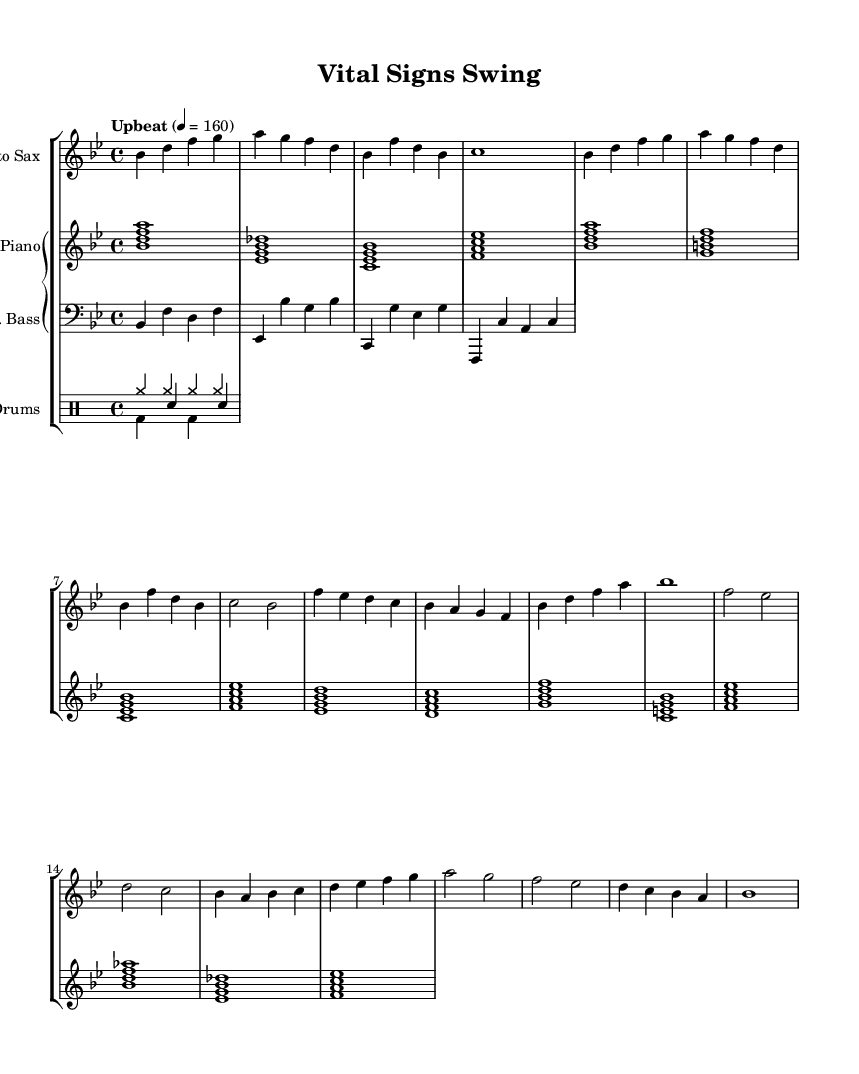What is the key signature of this music? The key signature is identified at the beginning of the sheet music, represented by the flat symbols. In this case, there are two flats (B flat and E flat) listed, indicating that the key is B flat major.
Answer: B flat major What is the time signature of this music? The time signature indicates how many beats are in each measure, shown at the beginning of the sheet music. Here, it is listed as 4/4, meaning there are four beats per measure, and the quarter note gets one beat.
Answer: 4/4 What is the tempo marking for this piece? The tempo marking is found in the first section of the sheet music and indicates the speed at which the piece should be played. It is described as "Upbeat" with a metronome marking of 160 beats per minute.
Answer: Upbeat, 160 How many measures are in the A Section? The A Section is a contained part of the music indicated by distinct musical phrases. Upon counting the measures, there are a total of 8 measures in the A Section of the music.
Answer: 8 What type of instruments are included in this arrangement? The instrument names are specified for each staff. Based on the provided parts, the instruments included are Alto Sax, Electric Piano, Electric Bass, and Drums.
Answer: Alto Sax, Electric Piano, Electric Bass, Drums What is the rhythmic feel conveyed in the song? The rhythmic feel or groove can be inferred from the time signature, tempo, and style of the music. Given the combination of an upbeat tempo and a swing feel, the song conveys a lively and energetic rhythm characteristic of Jazz.
Answer: Energetic swing What is the chord progression used in the B Section? The B Section contains a series of chord symbols according to the rhythm and melody that correspond to the measures. By analyzing it, the chord progression for this section is identified as B flat major, E flat major, C minor, F major, etc.
Answer: B flat major, E flat major, C minor, F major 